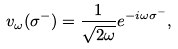Convert formula to latex. <formula><loc_0><loc_0><loc_500><loc_500>v _ { \omega } ( \sigma ^ { - } ) = \frac { 1 } { \sqrt { 2 \omega } } e ^ { - i \omega \sigma ^ { - } } ,</formula> 